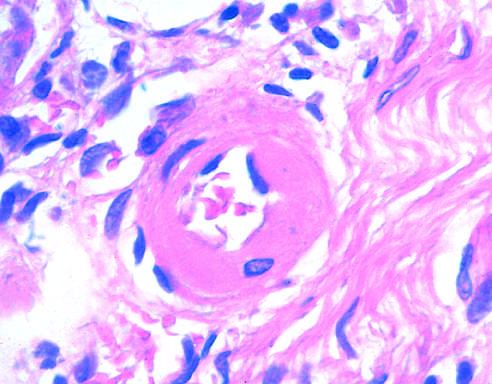s the arteriolar wall thickened with the deposition of amorphous proteinaceous material hyalinized?
Answer the question using a single word or phrase. Yes 